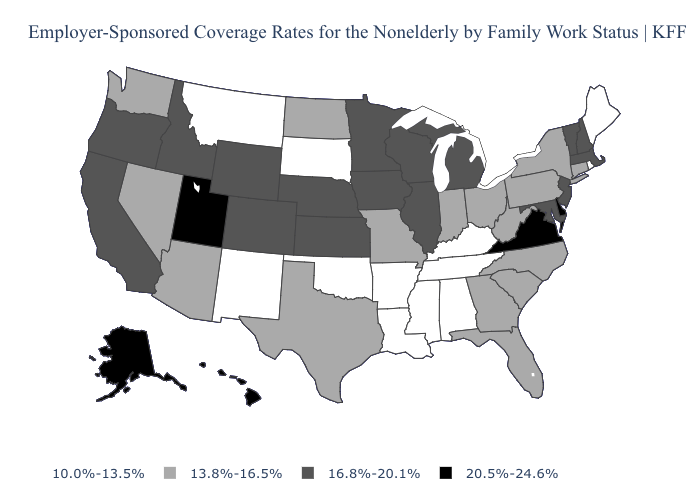Name the states that have a value in the range 16.8%-20.1%?
Short answer required. California, Colorado, Idaho, Illinois, Iowa, Kansas, Maryland, Massachusetts, Michigan, Minnesota, Nebraska, New Hampshire, New Jersey, Oregon, Vermont, Wisconsin, Wyoming. Name the states that have a value in the range 10.0%-13.5%?
Short answer required. Alabama, Arkansas, Kentucky, Louisiana, Maine, Mississippi, Montana, New Mexico, Oklahoma, Rhode Island, South Dakota, Tennessee. What is the value of New Jersey?
Keep it brief. 16.8%-20.1%. What is the value of Massachusetts?
Answer briefly. 16.8%-20.1%. Name the states that have a value in the range 10.0%-13.5%?
Answer briefly. Alabama, Arkansas, Kentucky, Louisiana, Maine, Mississippi, Montana, New Mexico, Oklahoma, Rhode Island, South Dakota, Tennessee. Name the states that have a value in the range 20.5%-24.6%?
Answer briefly. Alaska, Delaware, Hawaii, Utah, Virginia. Name the states that have a value in the range 10.0%-13.5%?
Give a very brief answer. Alabama, Arkansas, Kentucky, Louisiana, Maine, Mississippi, Montana, New Mexico, Oklahoma, Rhode Island, South Dakota, Tennessee. Is the legend a continuous bar?
Answer briefly. No. What is the value of Alaska?
Write a very short answer. 20.5%-24.6%. What is the highest value in the USA?
Give a very brief answer. 20.5%-24.6%. Does the first symbol in the legend represent the smallest category?
Answer briefly. Yes. Among the states that border Utah , does Arizona have the lowest value?
Quick response, please. No. What is the value of Arkansas?
Give a very brief answer. 10.0%-13.5%. What is the highest value in the Northeast ?
Keep it brief. 16.8%-20.1%. Does Mississippi have the lowest value in the South?
Give a very brief answer. Yes. 